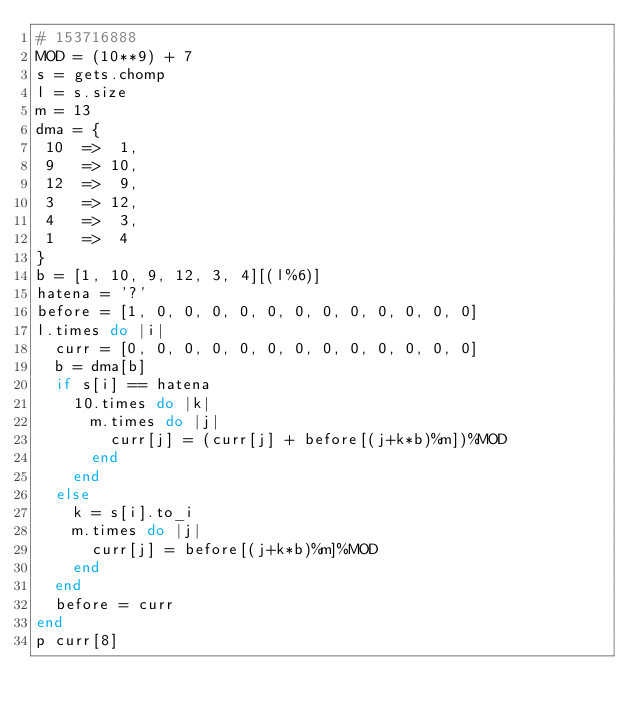Convert code to text. <code><loc_0><loc_0><loc_500><loc_500><_Ruby_># 153716888
MOD = (10**9) + 7
s = gets.chomp
l = s.size
m = 13
dma = {
 10  =>  1,
 9   => 10,
 12  =>  9,
 3   => 12,
 4   =>  3,
 1   =>  4
}
b = [1, 10, 9, 12, 3, 4][(l%6)]
hatena = '?'
before = [1, 0, 0, 0, 0, 0, 0, 0, 0, 0, 0, 0, 0]
l.times do |i|
  curr = [0, 0, 0, 0, 0, 0, 0, 0, 0, 0, 0, 0, 0]
  b = dma[b]
  if s[i] == hatena
    10.times do |k|
      m.times do |j|
        curr[j] = (curr[j] + before[(j+k*b)%m])%MOD
      end
    end
  else
    k = s[i].to_i
    m.times do |j|
      curr[j] = before[(j+k*b)%m]%MOD
    end
  end
  before = curr
end
p curr[8]</code> 